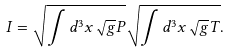<formula> <loc_0><loc_0><loc_500><loc_500>I = \sqrt { \int d ^ { 3 } x \sqrt { g } P } \sqrt { \int d ^ { 3 } x \sqrt { g } { T } } .</formula> 